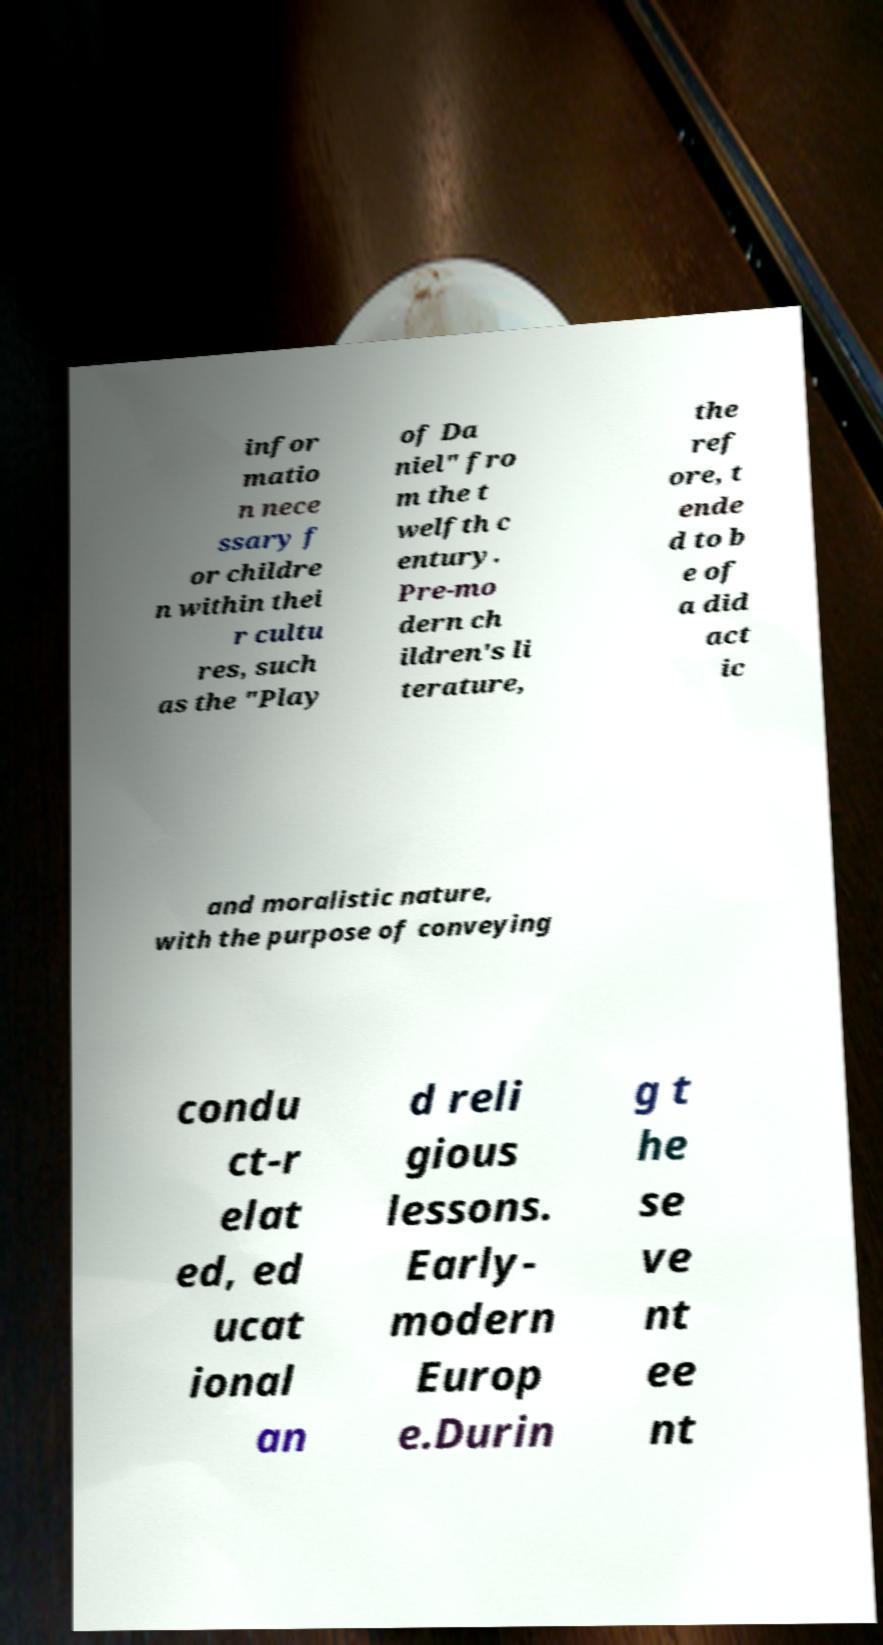Could you extract and type out the text from this image? infor matio n nece ssary f or childre n within thei r cultu res, such as the "Play of Da niel" fro m the t welfth c entury. Pre-mo dern ch ildren's li terature, the ref ore, t ende d to b e of a did act ic and moralistic nature, with the purpose of conveying condu ct-r elat ed, ed ucat ional an d reli gious lessons. Early- modern Europ e.Durin g t he se ve nt ee nt 